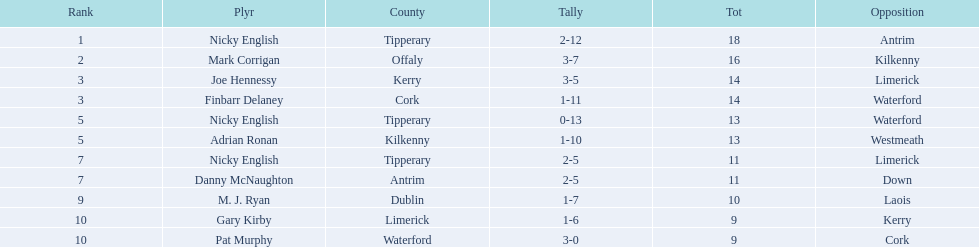What numbers are in the total column? 18, 16, 14, 14, 13, 13, 11, 11, 10, 9, 9. What row has the number 10 in the total column? 9, M. J. Ryan, Dublin, 1-7, 10, Laois. What name is in the player column for this row? M. J. Ryan. 